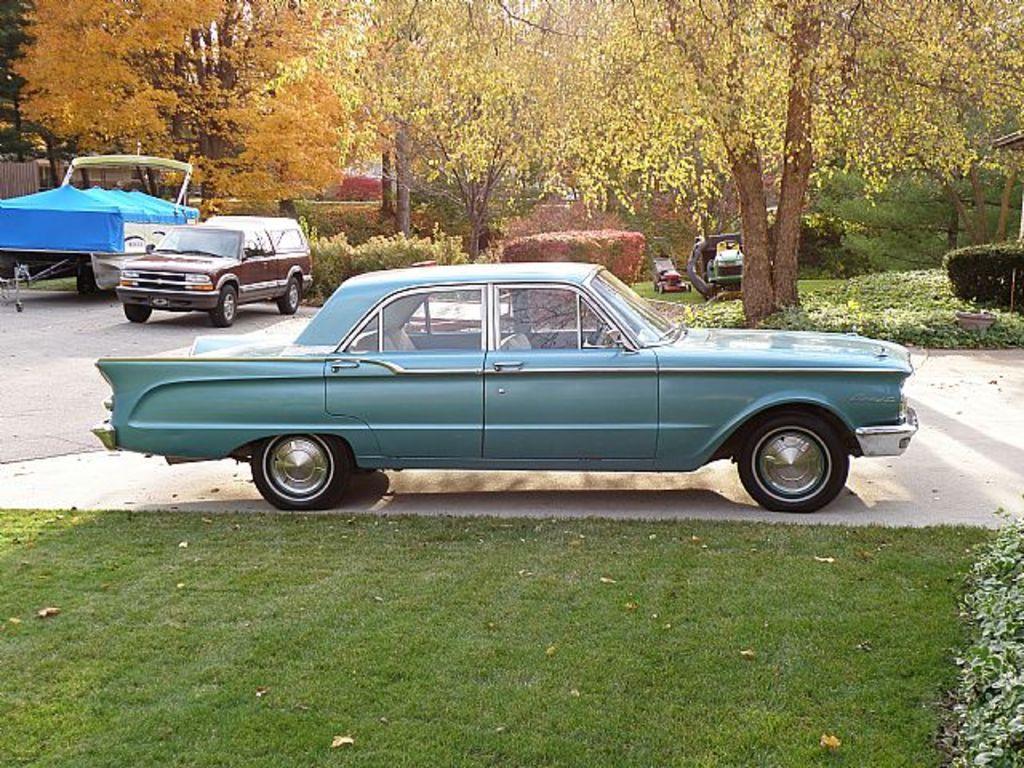Please provide a concise description of this image. In the center of the image there are vehicles. In the background there are trees. At the bottom there is grass and we can see bushes. 